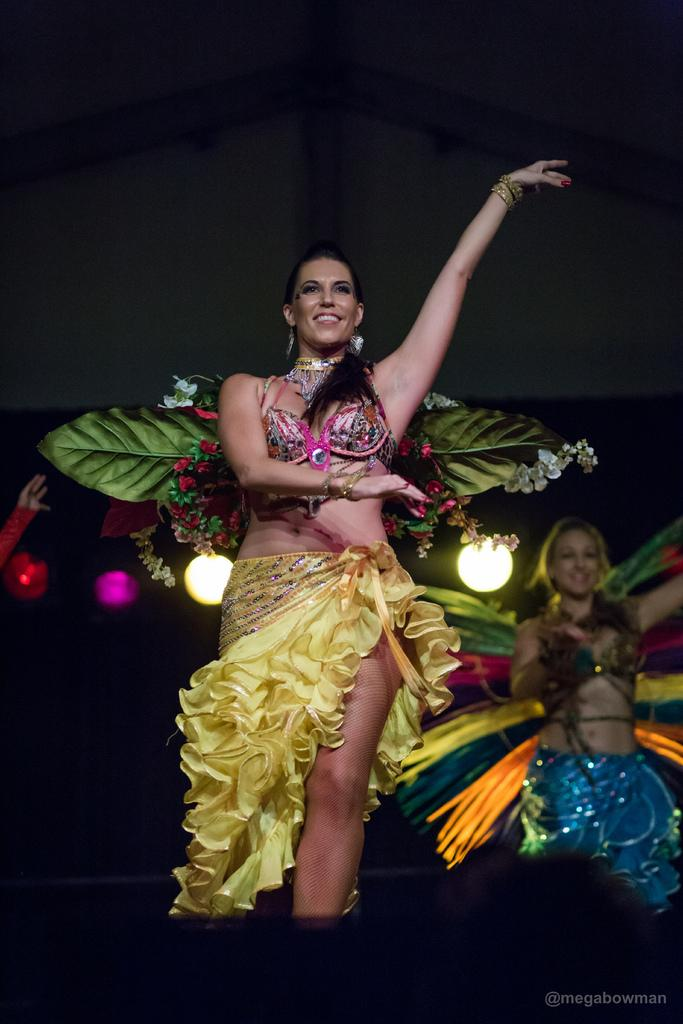What are the girls in the image doing? The girls are performing in the image. Where are the girls performing? The girls are on a dais. What can be seen in the background of the image? There is a wall and lights in the background of the image. What type of silver appliance can be seen on the dais in the image? There is no silver appliance present on the dais in the image. How many ducks are visible in the image? There are no ducks present in the image. 